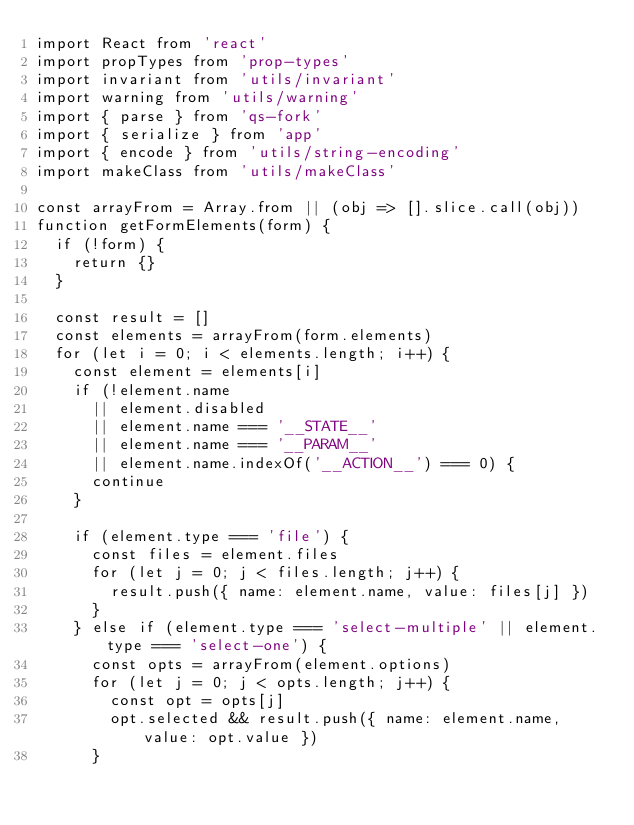<code> <loc_0><loc_0><loc_500><loc_500><_JavaScript_>import React from 'react'
import propTypes from 'prop-types'
import invariant from 'utils/invariant'
import warning from 'utils/warning'
import { parse } from 'qs-fork'
import { serialize } from 'app'
import { encode } from 'utils/string-encoding'
import makeClass from 'utils/makeClass'

const arrayFrom = Array.from || (obj => [].slice.call(obj))
function getFormElements(form) {
  if (!form) {
    return {}
  }

  const result = []
  const elements = arrayFrom(form.elements)
  for (let i = 0; i < elements.length; i++) {
    const element = elements[i]
    if (!element.name
      || element.disabled
      || element.name === '__STATE__'
      || element.name === '__PARAM__'
      || element.name.indexOf('__ACTION__') === 0) {
      continue
    }

    if (element.type === 'file') {
      const files = element.files
      for (let j = 0; j < files.length; j++) {
        result.push({ name: element.name, value: files[j] })
      }
    } else if (element.type === 'select-multiple' || element.type === 'select-one') {
      const opts = arrayFrom(element.options)
      for (let j = 0; j < opts.length; j++) {
        const opt = opts[j]
        opt.selected && result.push({ name: element.name, value: opt.value })
      }</code> 